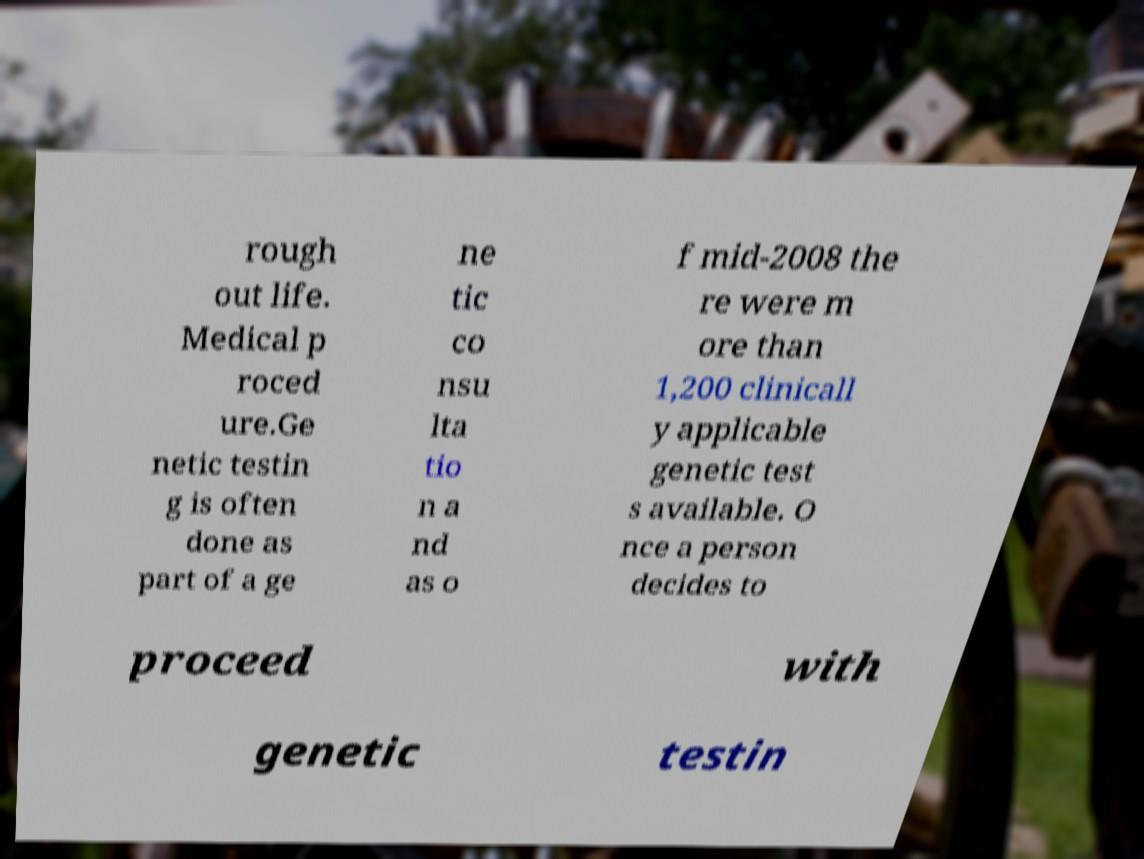Please read and relay the text visible in this image. What does it say? rough out life. Medical p roced ure.Ge netic testin g is often done as part of a ge ne tic co nsu lta tio n a nd as o f mid-2008 the re were m ore than 1,200 clinicall y applicable genetic test s available. O nce a person decides to proceed with genetic testin 